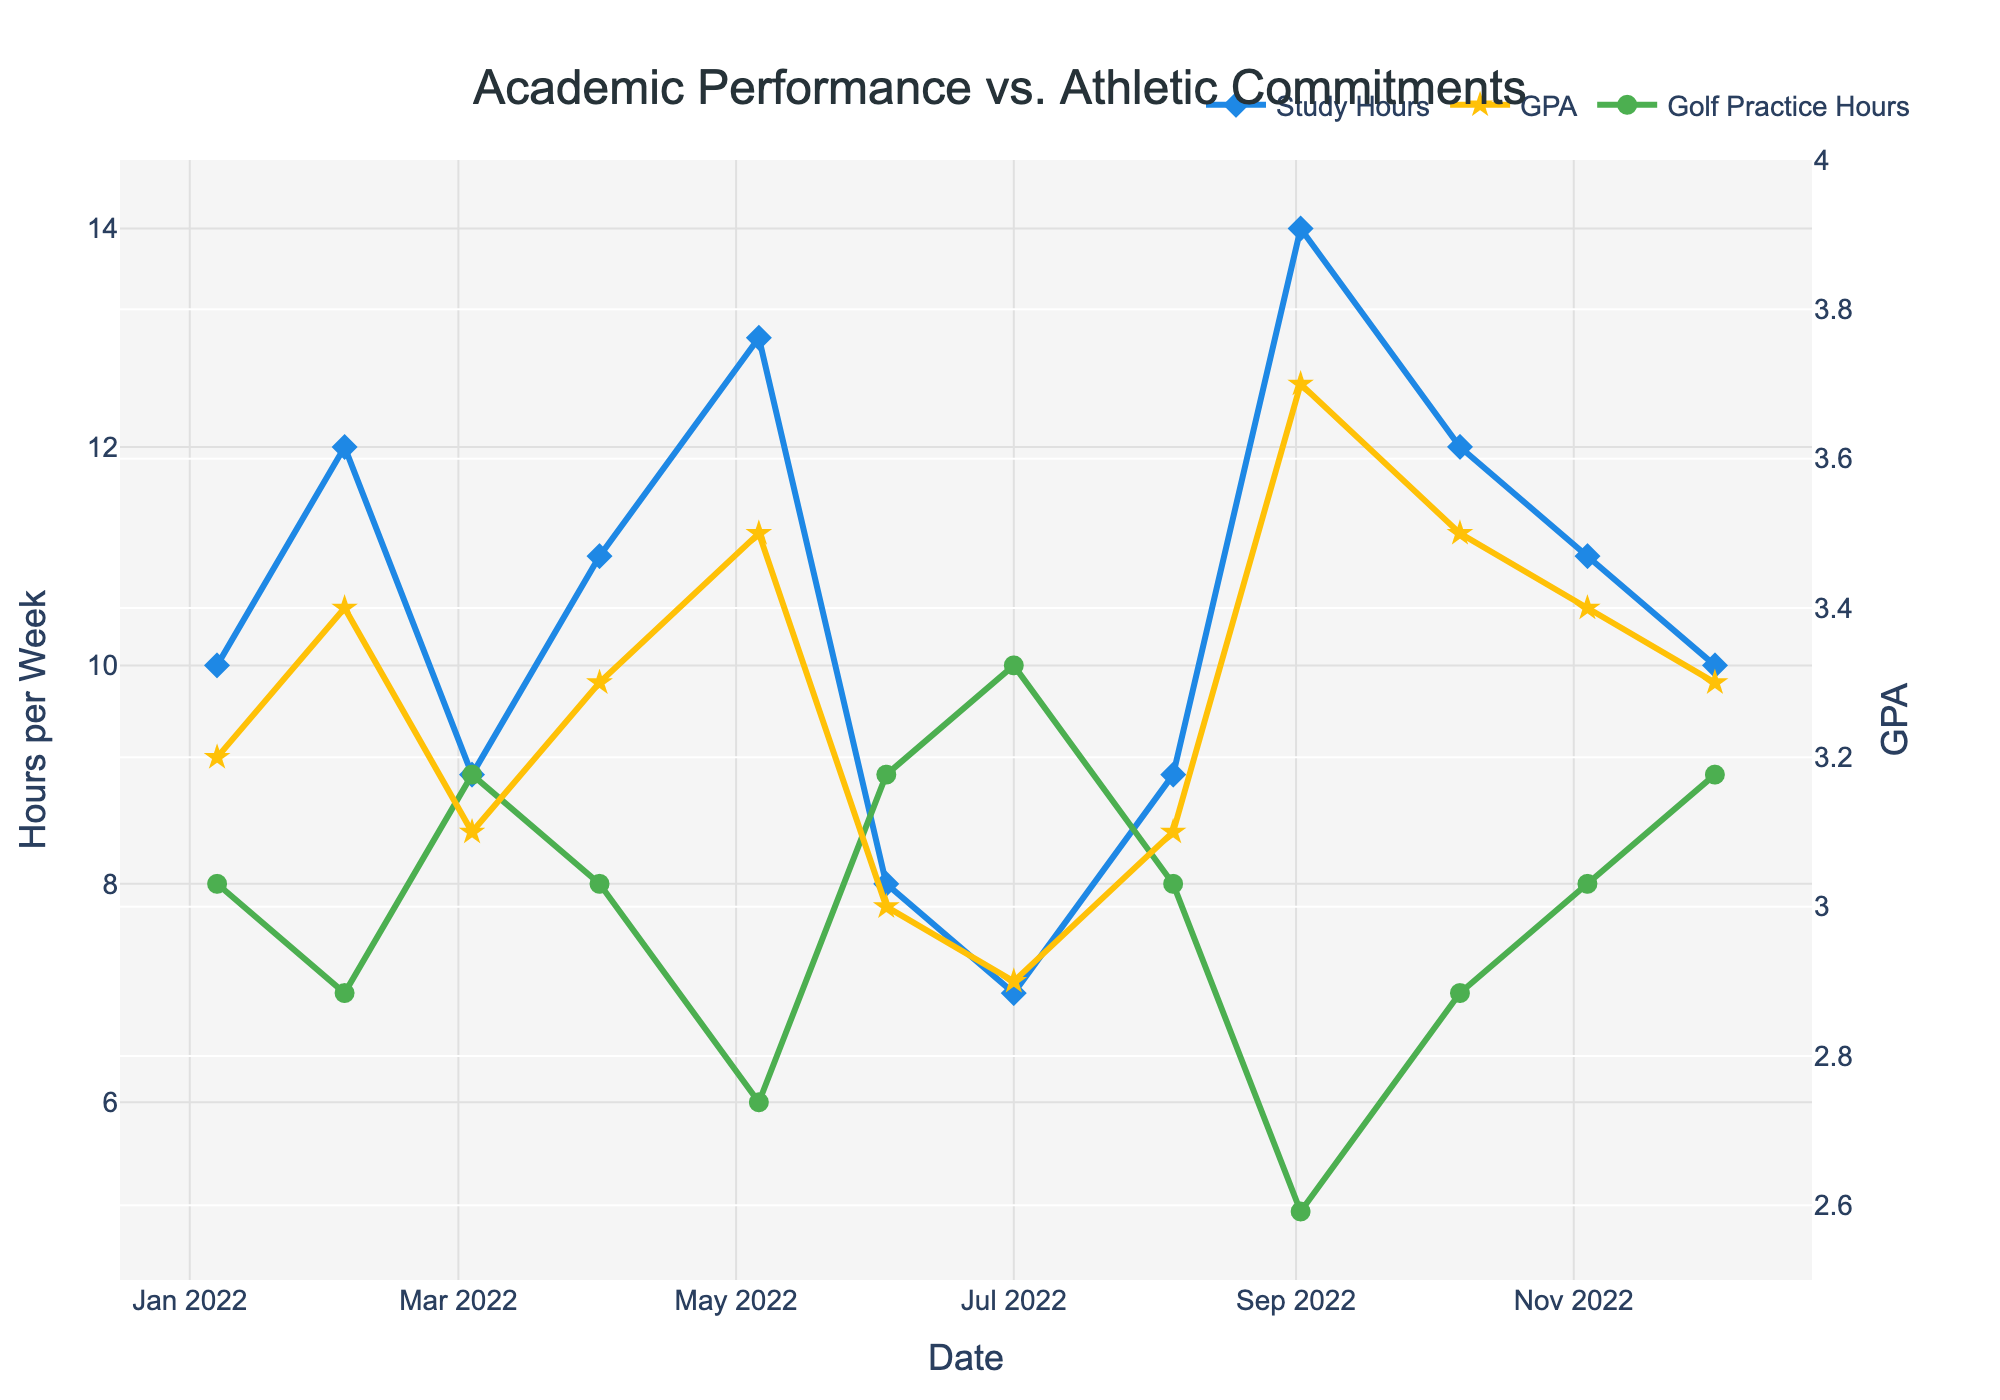What is the title of the figure? The title of the figure is located at the top and provides a summary of what the figure represents. Here, it reads "Academic Performance vs. Athletic Commitments."
Answer: Academic Performance vs. Athletic Commitments What color represents the Golf Practice Hours trend? By examining the legend, we note that the Golf Practice Hours trend is represented by green lines and markers.
Answer: Green When did the highest GPA occur, and what was its value? Look for the peak value along the GPA (yellow) trend line and read the corresponding date and number next to it. It occurs in September 2022, with a GPA of 3.7.
Answer: September 2022, 3.7 How do the hours studied per week change from January to December? Track the blue line (Hours Studied Per Week) from January (10 hours) to December (10 hours) and observe the variations within these months. This involves checking each point on the blue line.
Answer: Fluctuates, then returns to 10 hours What is the average GPA from January to December? Add all the GPA values (3.2 + 3.4 + 3.1 + 3.3 + 3.5 + 3.0 + 2.9 + 3.1 + 3.7 + 3.5 + 3.4 + 3.3) and divide by the number of months (12). The sum is 39.4 and the average is 39.4/12.
Answer: 3.28 Which month had the lowest number of golf practice hours and how many hours were they? Identify the minimum value in the green Golf Practice Hours trend and read the corresponding month. The least number of golf practice hours occurred in September, with 5 hours.
Answer: September, 5 hours Is there a month where hours studied and golf practice hours were equal? Compare the blue and green lines at each point. No month has equal values.
Answer: No How does the trend in GPA generally relate to hours studied per week? Observe the trends and note how in most months, a higher number of hours studied per week (blue line) often corresponds to a higher GPA (yellow line), suggesting a positive correlation.
Answer: Positive correlation What is the change in hours spent on golf practice from June to July? Find the number of hours in June (9) and July (10), and compute the difference. The increase is 10 - 9.
Answer: Increased by 1 hour 